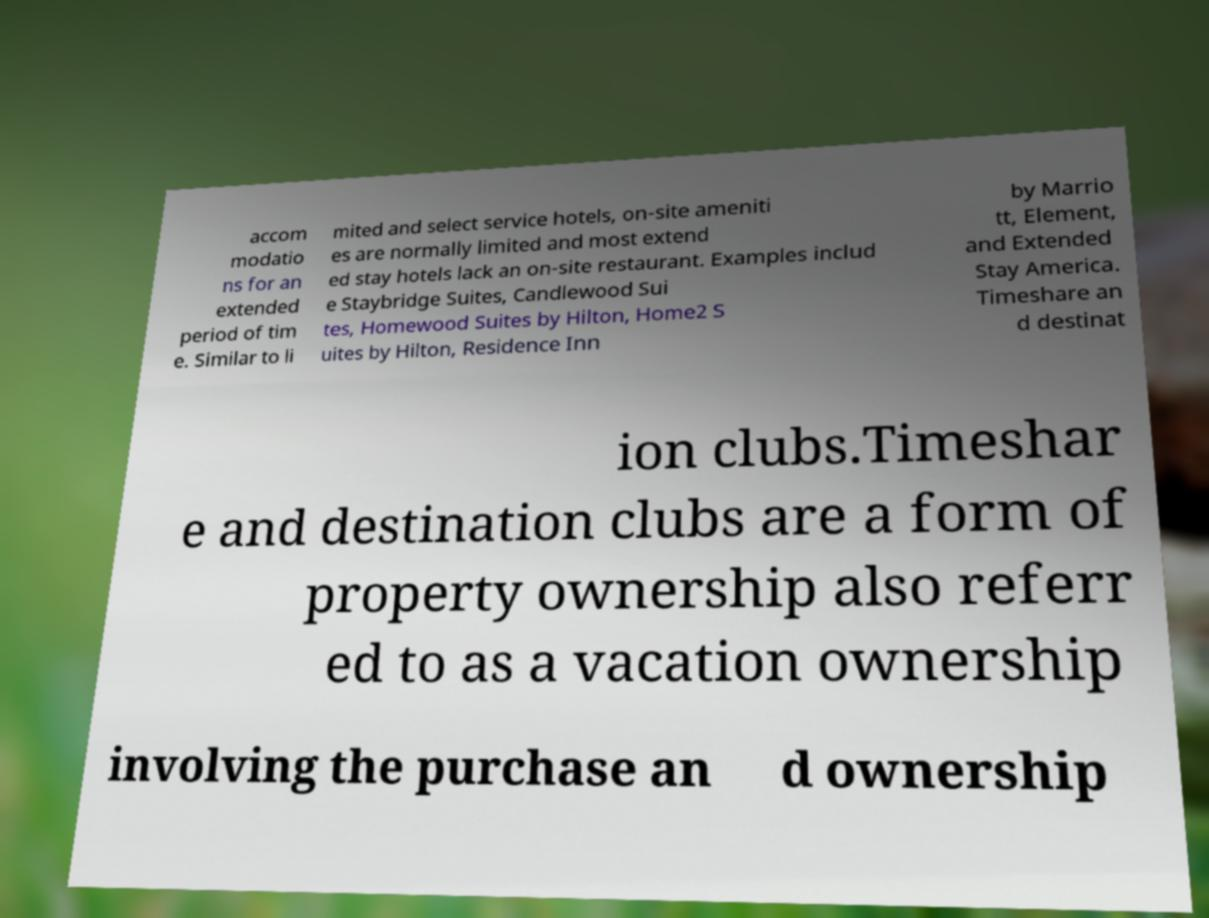Can you read and provide the text displayed in the image?This photo seems to have some interesting text. Can you extract and type it out for me? accom modatio ns for an extended period of tim e. Similar to li mited and select service hotels, on-site ameniti es are normally limited and most extend ed stay hotels lack an on-site restaurant. Examples includ e Staybridge Suites, Candlewood Sui tes, Homewood Suites by Hilton, Home2 S uites by Hilton, Residence Inn by Marrio tt, Element, and Extended Stay America. Timeshare an d destinat ion clubs.Timeshar e and destination clubs are a form of property ownership also referr ed to as a vacation ownership involving the purchase an d ownership 